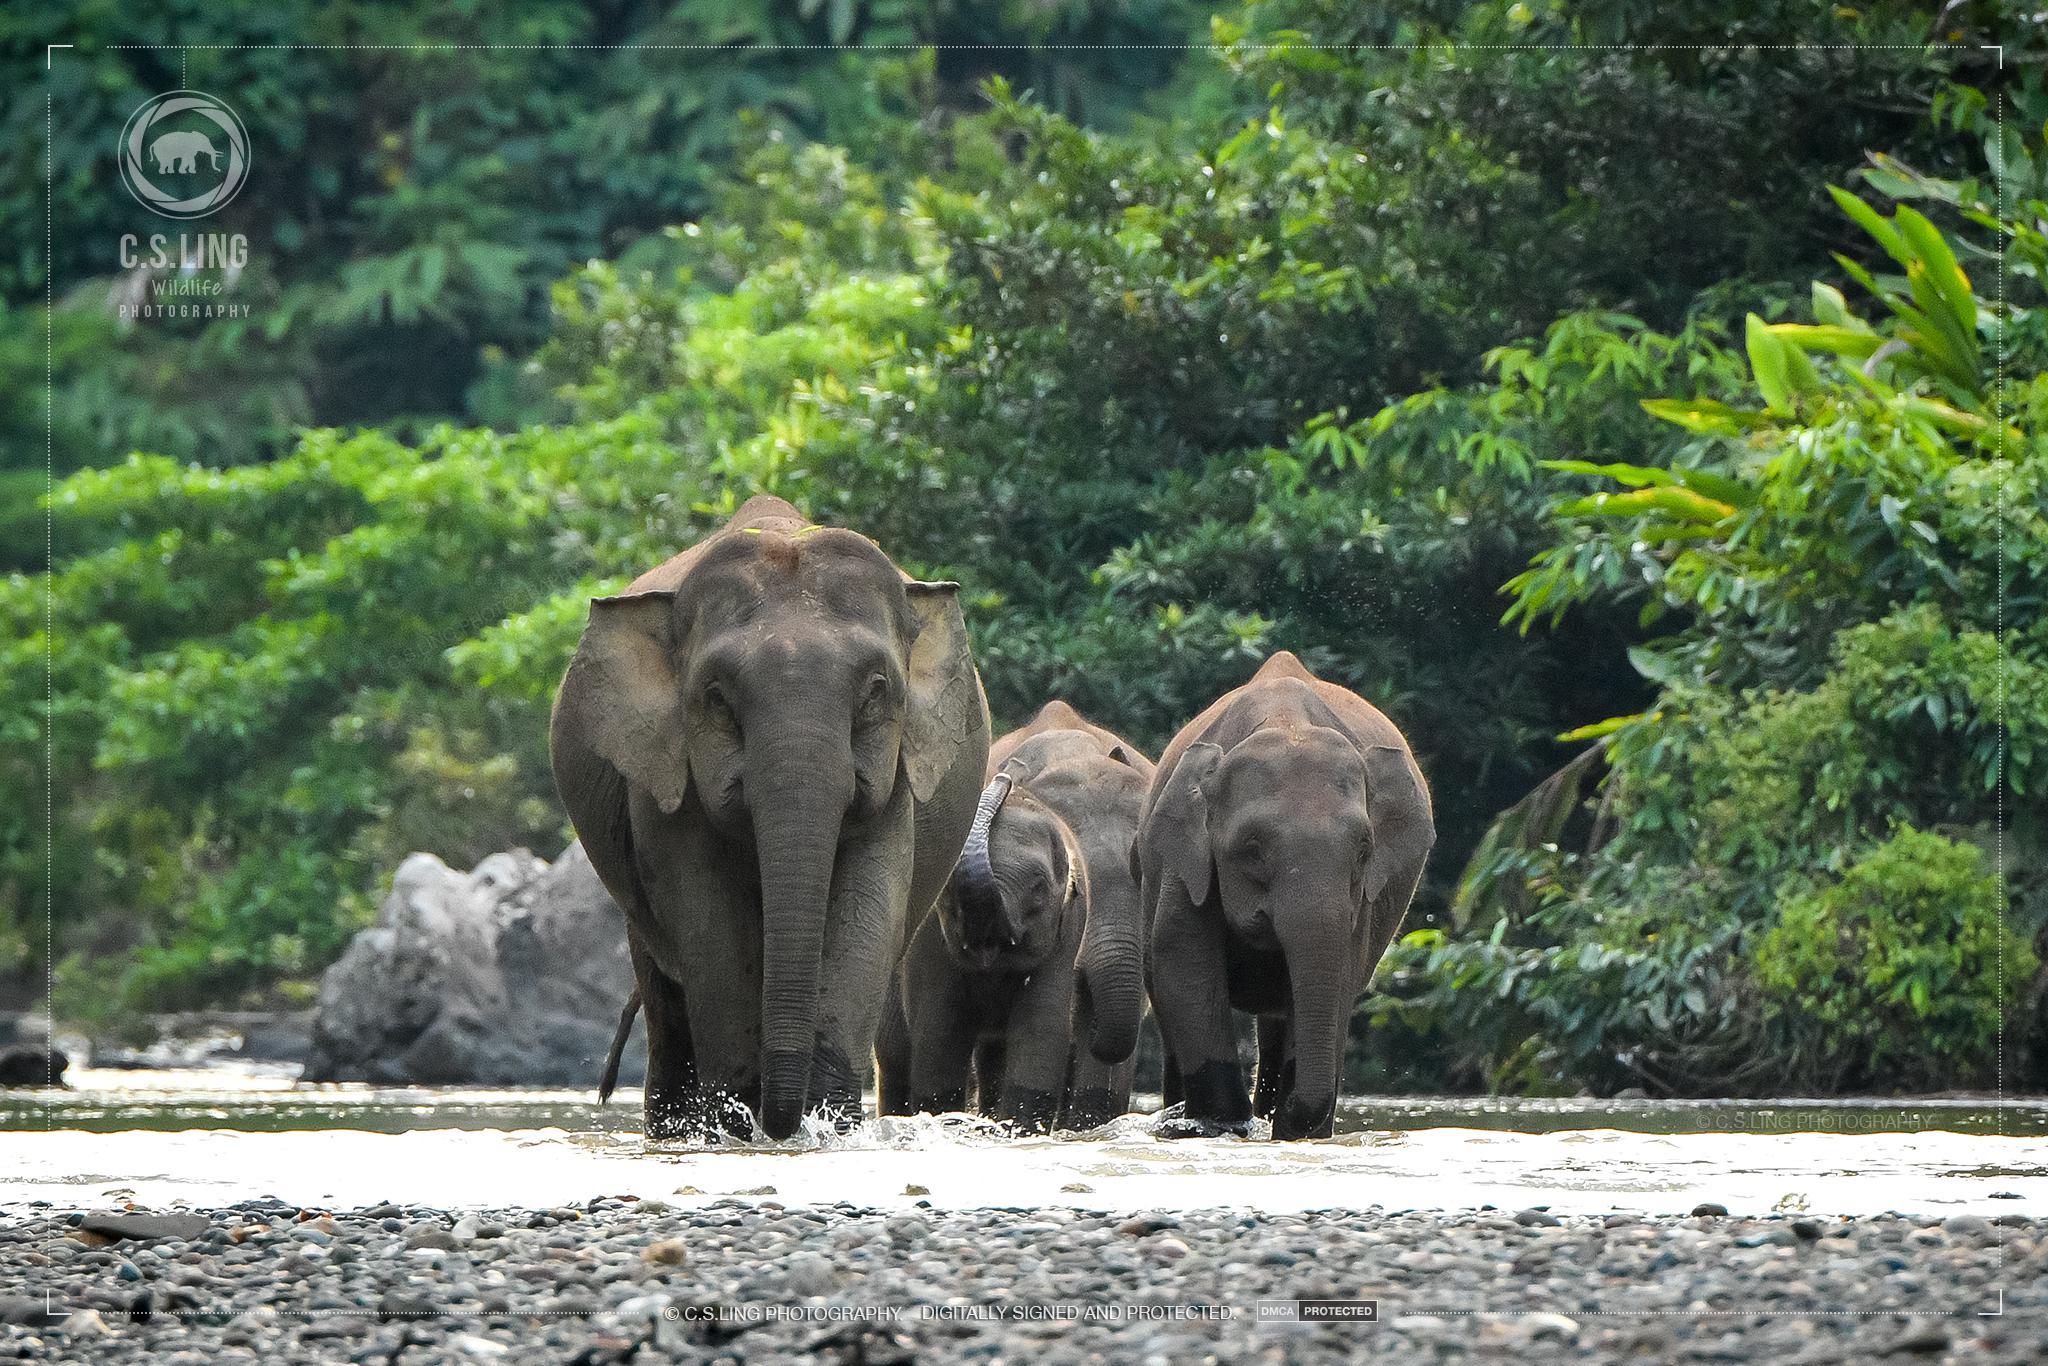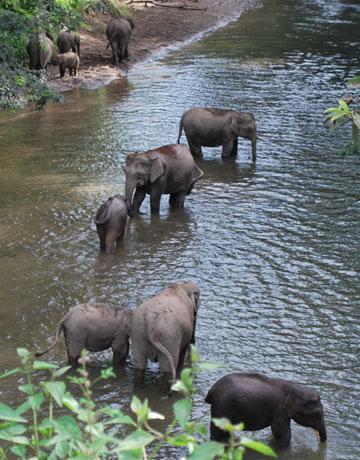The first image is the image on the left, the second image is the image on the right. Assess this claim about the two images: "One image has only one elephant in it.". Correct or not? Answer yes or no. No. 